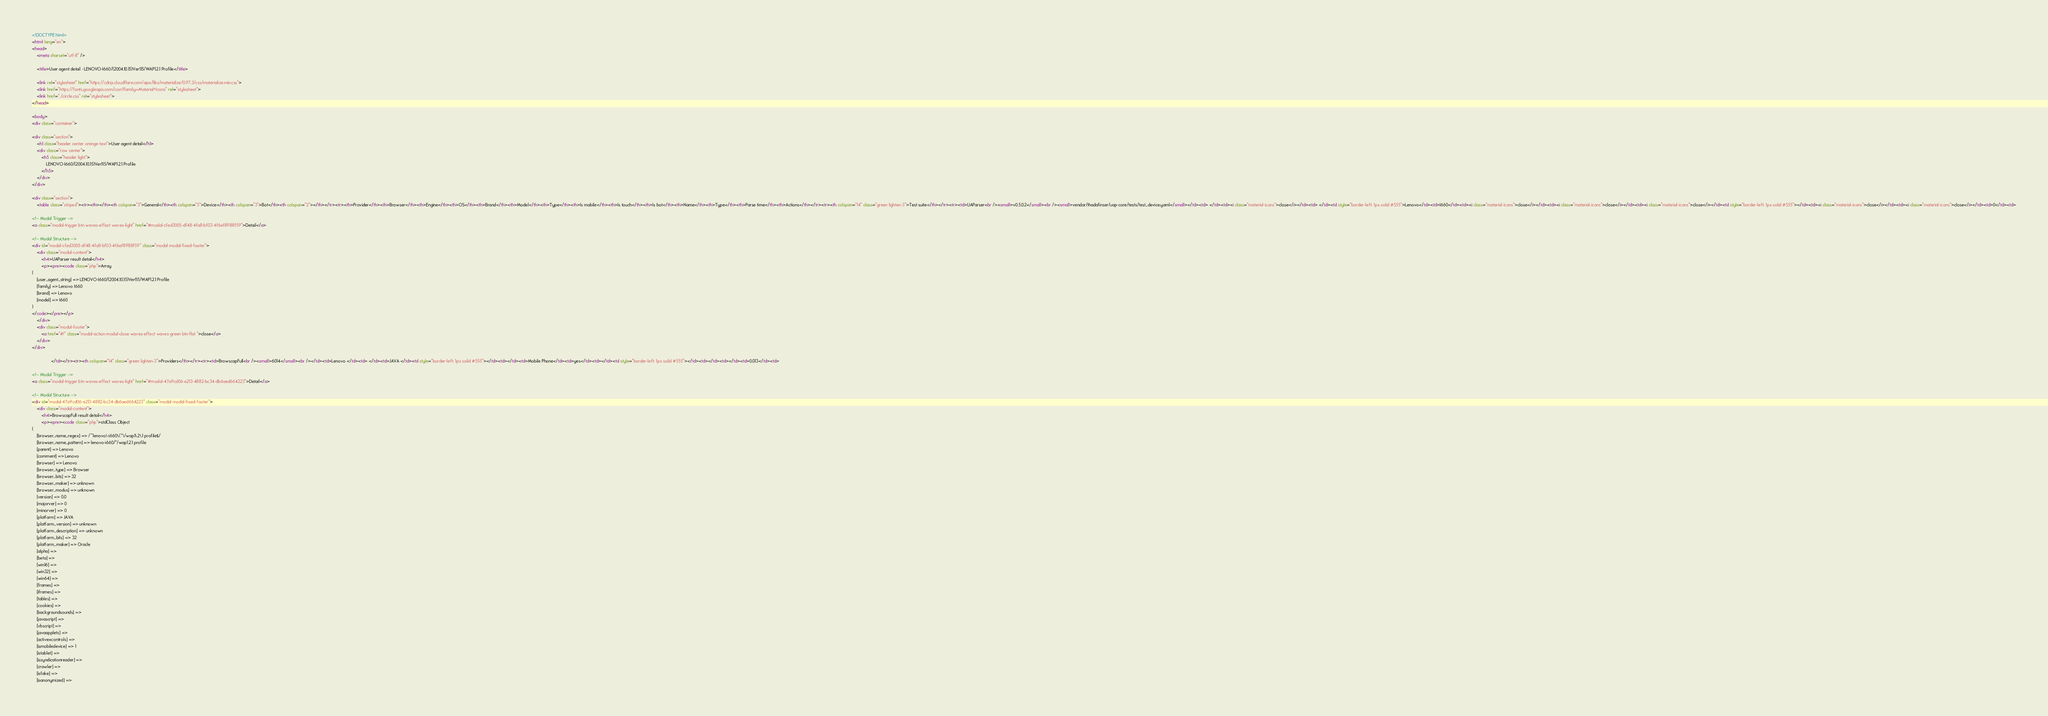Convert code to text. <code><loc_0><loc_0><loc_500><loc_500><_HTML_>
<!DOCTYPE html>
<html lang="en">
<head>
    <meta charset="utf-8" />
            
    <title>User agent detail - LENOVO-I660/(2004.10.15)Ver115/WAP1.2.1 Profile</title>
        
    <link rel="stylesheet" href="https://cdnjs.cloudflare.com/ajax/libs/materialize/0.97.3/css/materialize.min.css">
    <link href="https://fonts.googleapis.com/icon?family=Material+Icons" rel="stylesheet">
    <link href="../circle.css" rel="stylesheet">
</head>
        
<body>
<div class="container">
    
<div class="section">
	<h1 class="header center orange-text">User agent detail</h1>
	<div class="row center">
        <h5 class="header light">
            LENOVO-I660/(2004.10.15)Ver115/WAP1.2.1 Profile
        </h5>
	</div>
</div>   

<div class="section">
    <table class="striped"><tr><th></th><th colspan="3">General</th><th colspan="5">Device</th><th colspan="3">Bot</th><th colspan="2"></th></tr><tr><th>Provider</th><th>Browser</th><th>Engine</th><th>OS</th><th>Brand</th><th>Model</th><th>Type</th><th>Is mobile</th><th>Is touch</th><th>Is bot</th><th>Name</th><th>Type</th><th>Parse time</th><th>Actions</th></tr><tr><th colspan="14" class="green lighten-3">Test suite</th></tr><tr><td>UAParser<br /><small>v0.5.0.2</small><br /><small>vendor/thadafinser/uap-core/tests/test_device.yaml</small></td><td> </td><td><i class="material-icons">close</i></td><td> </td><td style="border-left: 1px solid #555">Lenovo</td><td>I660</td><td><i class="material-icons">close</i></td><td><i class="material-icons">close</i></td><td><i class="material-icons">close</i></td><td style="border-left: 1px solid #555"></td><td><i class="material-icons">close</i></td><td><i class="material-icons">close</i></td><td>0</td><td>
        
<!-- Modal Trigger -->
<a class="modal-trigger btn waves-effect waves-light" href="#modal-cfed3005-df48-4fa8-bf03-4f6ef8988f59">Detail</a>
        
<!-- Modal Structure -->
<div id="modal-cfed3005-df48-4fa8-bf03-4f6ef8988f59" class="modal modal-fixed-footer">
    <div class="modal-content">
        <h4>UAParser result detail</h4>
        <p><pre><code class="php">Array
(
    [user_agent_string] => LENOVO-I660/(2004.10.15)Ver115/WAP1.2.1 Profile
    [family] => Lenovo I660
    [brand] => Lenovo
    [model] => I660
)
</code></pre></p>
    </div>
    <div class="modal-footer">
        <a href="#!" class="modal-action modal-close waves-effect waves-green btn-flat ">close</a>
    </div>
</div>
        
                </td></tr><tr><th colspan="14" class="green lighten-3">Providers</th></tr><tr><td>BrowscapFull<br /><small>6014</small><br /></td><td>Lenovo </td><td> </td><td>JAVA </td><td style="border-left: 1px solid #555"></td><td></td><td>Mobile Phone</td><td>yes</td><td></td><td style="border-left: 1px solid #555"></td><td></td><td></td><td>0.013</td><td>
        
<!-- Modal Trigger -->
<a class="modal-trigger btn waves-effect waves-light" href="#modal-47a9cd06-e213-4882-bc34-db6aed664223">Detail</a>
        
<!-- Modal Structure -->
<div id="modal-47a9cd06-e213-4882-bc34-db6aed664223" class="modal modal-fixed-footer">
    <div class="modal-content">
        <h4>BrowscapFull result detail</h4>
        <p><pre><code class="php">stdClass Object
(
    [browser_name_regex] => /^lenovo\-i660\/.*\/wap1\.2\.1 profile$/
    [browser_name_pattern] => lenovo-i660/*/wap1.2.1 profile
    [parent] => Lenovo
    [comment] => Lenovo
    [browser] => Lenovo
    [browser_type] => Browser
    [browser_bits] => 32
    [browser_maker] => unknown
    [browser_modus] => unknown
    [version] => 0.0
    [majorver] => 0
    [minorver] => 0
    [platform] => JAVA
    [platform_version] => unknown
    [platform_description] => unknown
    [platform_bits] => 32
    [platform_maker] => Oracle
    [alpha] => 
    [beta] => 
    [win16] => 
    [win32] => 
    [win64] => 
    [frames] => 
    [iframes] => 
    [tables] => 
    [cookies] => 
    [backgroundsounds] => 
    [javascript] => 
    [vbscript] => 
    [javaapplets] => 
    [activexcontrols] => 
    [ismobiledevice] => 1
    [istablet] => 
    [issyndicationreader] => 
    [crawler] => 
    [isfake] => 
    [isanonymized] => </code> 